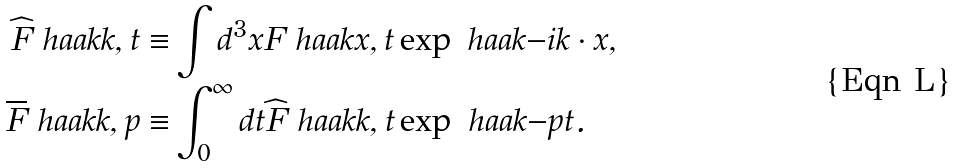<formula> <loc_0><loc_0><loc_500><loc_500>\widehat { F } \ h a a k { k , t } \equiv & \int d ^ { 3 } x F \ h a a k { x , t } \exp \ h a a k { - i k \cdot x } , \\ \overline { F } \ h a a k { k , p } \equiv & \int _ { 0 } ^ { \infty } d t \widehat { F } \ h a a k { k , t } \exp \ h a a k { - p t } .</formula> 